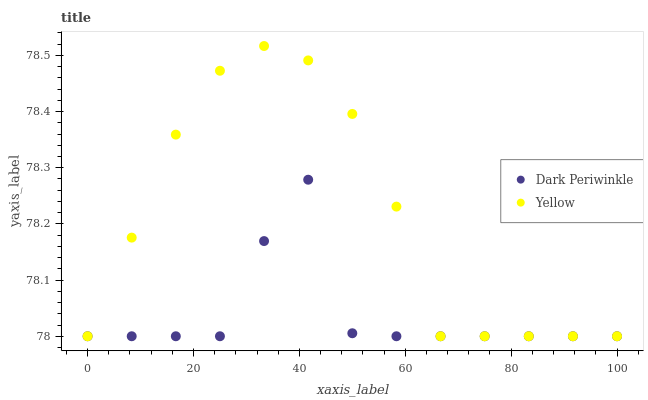Does Dark Periwinkle have the minimum area under the curve?
Answer yes or no. Yes. Does Yellow have the maximum area under the curve?
Answer yes or no. Yes. Does Yellow have the minimum area under the curve?
Answer yes or no. No. Is Yellow the smoothest?
Answer yes or no. Yes. Is Dark Periwinkle the roughest?
Answer yes or no. Yes. Is Yellow the roughest?
Answer yes or no. No. Does Dark Periwinkle have the lowest value?
Answer yes or no. Yes. Does Yellow have the highest value?
Answer yes or no. Yes. Does Dark Periwinkle intersect Yellow?
Answer yes or no. Yes. Is Dark Periwinkle less than Yellow?
Answer yes or no. No. Is Dark Periwinkle greater than Yellow?
Answer yes or no. No. 